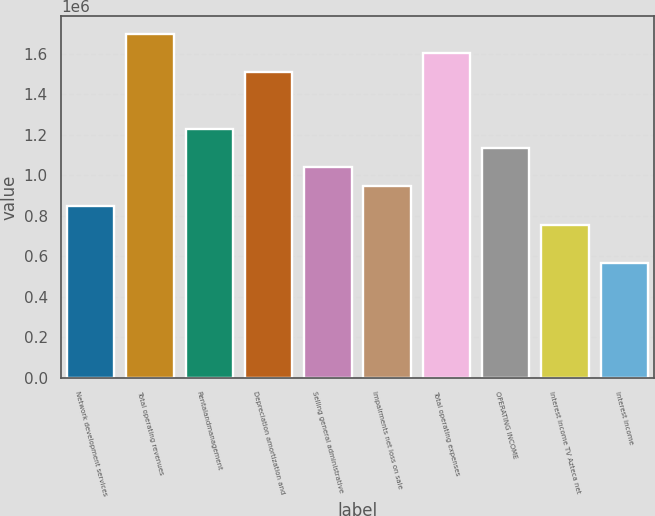Convert chart to OTSL. <chart><loc_0><loc_0><loc_500><loc_500><bar_chart><fcel>Network development services<fcel>Total operating revenues<fcel>Rentalandmanagement<fcel>Depreciation amortization and<fcel>Selling general administrative<fcel>Impairments net loss on sale<fcel>Total operating expenses<fcel>OPERATING INCOME<fcel>Interest income TV Azteca net<fcel>Interest income<nl><fcel>850307<fcel>1.70061e+06<fcel>1.22822e+06<fcel>1.51166e+06<fcel>1.03926e+06<fcel>944786<fcel>1.60614e+06<fcel>1.13374e+06<fcel>755829<fcel>566872<nl></chart> 